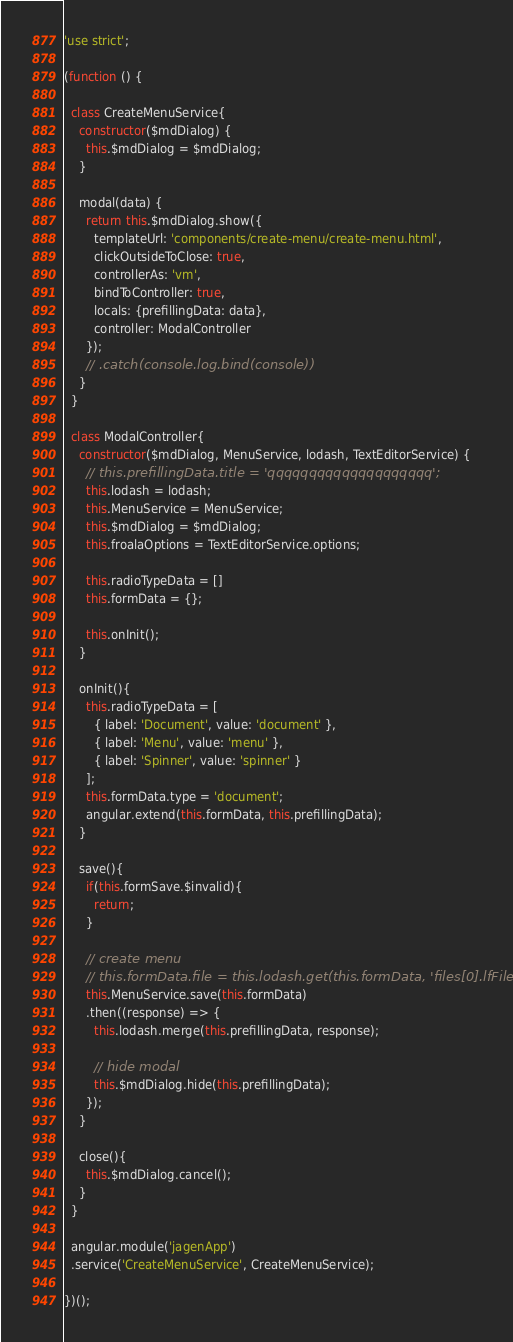Convert code to text. <code><loc_0><loc_0><loc_500><loc_500><_JavaScript_>'use strict';

(function () {

  class CreateMenuService{
    constructor($mdDialog) {
      this.$mdDialog = $mdDialog;
    }

    modal(data) {
      return this.$mdDialog.show({
        templateUrl: 'components/create-menu/create-menu.html',
        clickOutsideToClose: true,
        controllerAs: 'vm',
        bindToController: true,
        locals: {prefillingData: data},
        controller: ModalController
      });
      // .catch(console.log.bind(console))
    }
  }

  class ModalController{
    constructor($mdDialog, MenuService, lodash, TextEditorService) {
      // this.prefillingData.title = 'qqqqqqqqqqqqqqqqqqqq';
      this.lodash = lodash;
      this.MenuService = MenuService;
      this.$mdDialog = $mdDialog;
      this.froalaOptions = TextEditorService.options;

      this.radioTypeData = []
      this.formData = {};

      this.onInit();
    }

    onInit(){
      this.radioTypeData = [
        { label: 'Document', value: 'document' },
        { label: 'Menu', value: 'menu' },
        { label: 'Spinner', value: 'spinner' }
      ];
      this.formData.type = 'document';
      angular.extend(this.formData, this.prefillingData);
    }

    save(){
      if(this.formSave.$invalid){
        return;
      }

      // create menu
      // this.formData.file = this.lodash.get(this.formData, 'files[0].lfFile');
      this.MenuService.save(this.formData)
      .then((response) => {
        this.lodash.merge(this.prefillingData, response);

        // hide modal
        this.$mdDialog.hide(this.prefillingData);
      });
    }

    close(){
      this.$mdDialog.cancel();
    }
  }

  angular.module('jagenApp')
  .service('CreateMenuService', CreateMenuService);

})();
</code> 